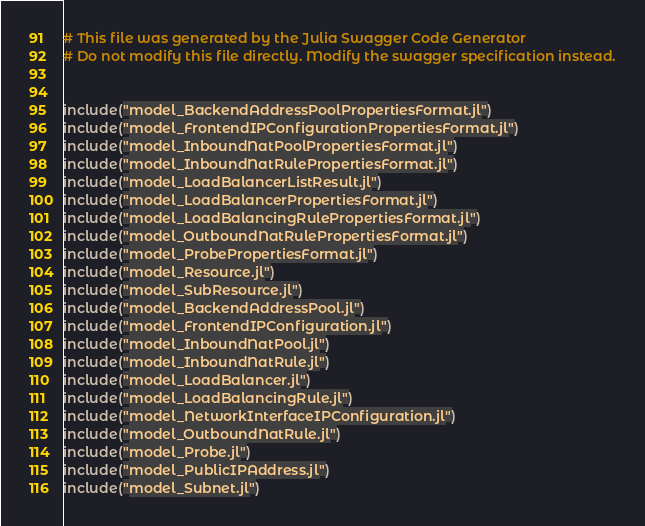<code> <loc_0><loc_0><loc_500><loc_500><_Julia_># This file was generated by the Julia Swagger Code Generator
# Do not modify this file directly. Modify the swagger specification instead.


include("model_BackendAddressPoolPropertiesFormat.jl")
include("model_FrontendIPConfigurationPropertiesFormat.jl")
include("model_InboundNatPoolPropertiesFormat.jl")
include("model_InboundNatRulePropertiesFormat.jl")
include("model_LoadBalancerListResult.jl")
include("model_LoadBalancerPropertiesFormat.jl")
include("model_LoadBalancingRulePropertiesFormat.jl")
include("model_OutboundNatRulePropertiesFormat.jl")
include("model_ProbePropertiesFormat.jl")
include("model_Resource.jl")
include("model_SubResource.jl")
include("model_BackendAddressPool.jl")
include("model_FrontendIPConfiguration.jl")
include("model_InboundNatPool.jl")
include("model_InboundNatRule.jl")
include("model_LoadBalancer.jl")
include("model_LoadBalancingRule.jl")
include("model_NetworkInterfaceIPConfiguration.jl")
include("model_OutboundNatRule.jl")
include("model_Probe.jl")
include("model_PublicIPAddress.jl")
include("model_Subnet.jl")
</code> 